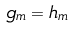<formula> <loc_0><loc_0><loc_500><loc_500>g _ { m } = h _ { m }</formula> 